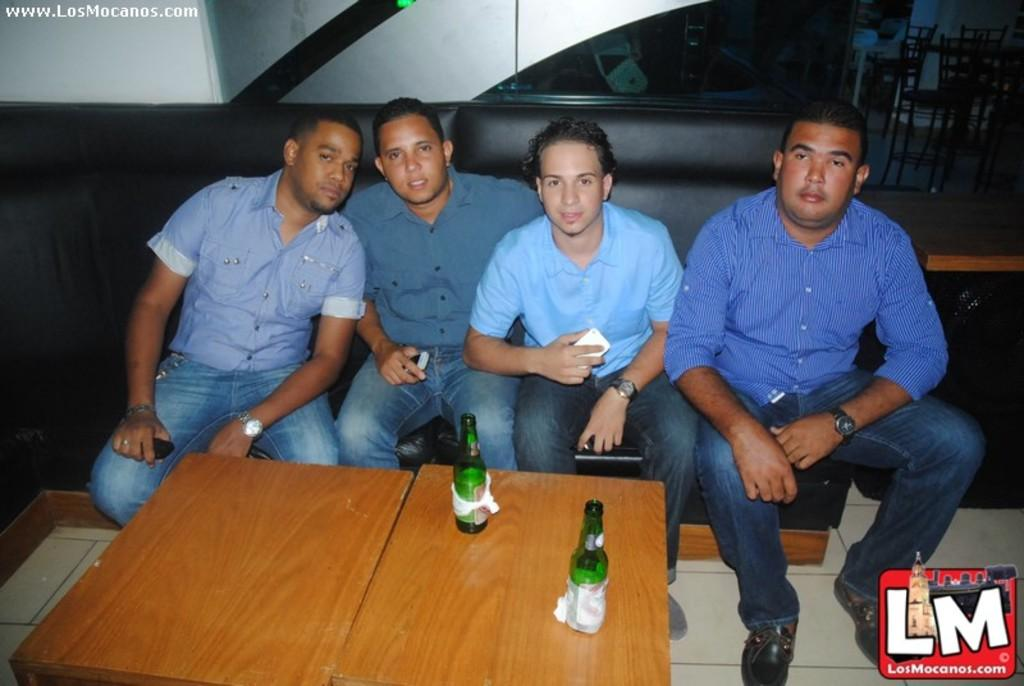How many people are present in the image? There are four people in the image. What are the people doing in the image? The people are sitting on a sofa. How many tables can be seen in the image? There are two tables in the image. What is on the tables? There are two bottles on the tables on the tables. What type of sand can be seen on the tramp in the image? There is no tramp or sand present in the image. What type of beef is being served on the plates in the image? There is no beef or plates present in the image. 